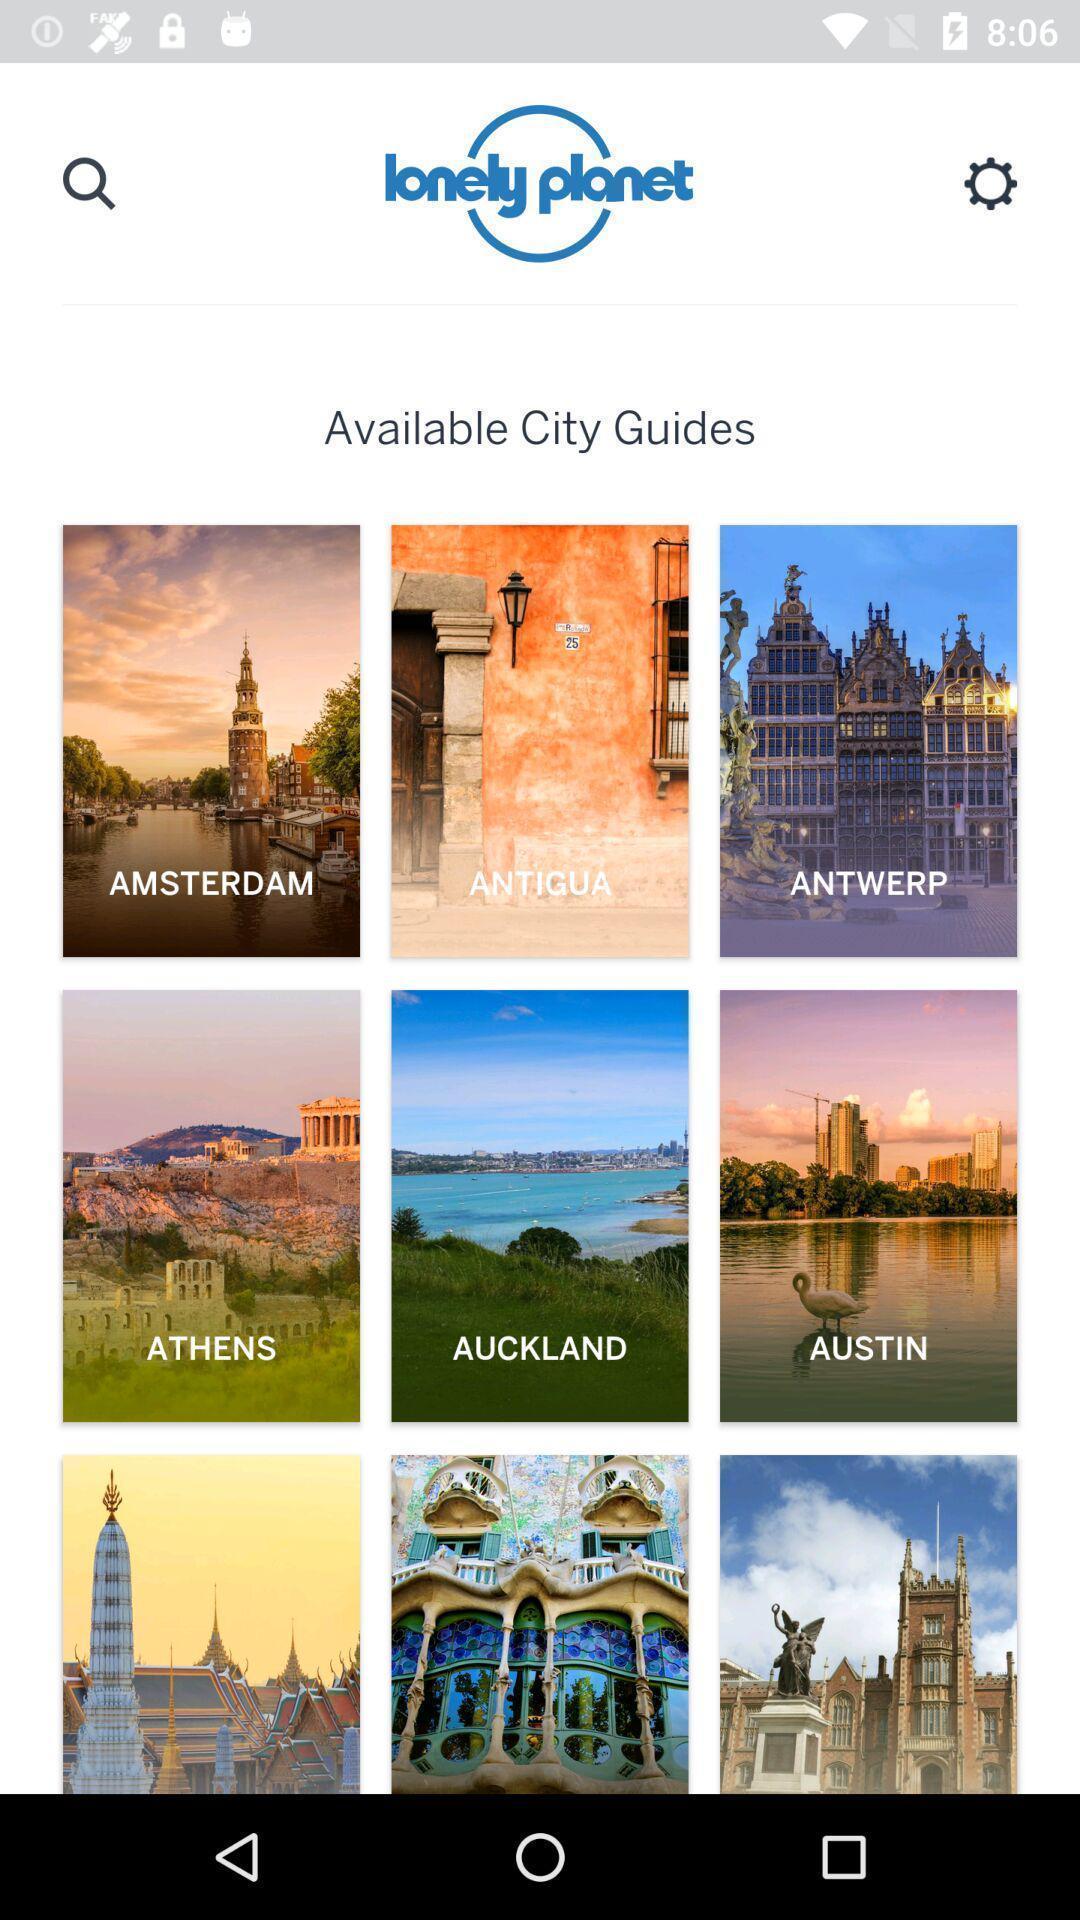Give me a summary of this screen capture. Page displaying information about different location. 